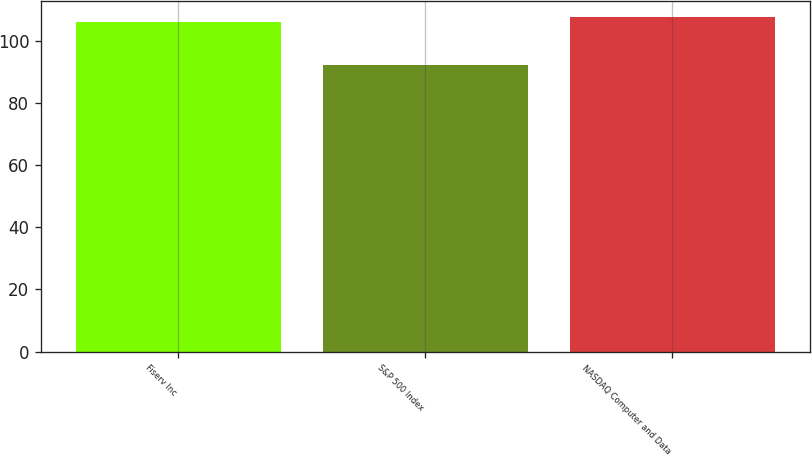<chart> <loc_0><loc_0><loc_500><loc_500><bar_chart><fcel>Fiserv Inc<fcel>S&P 500 Index<fcel>NASDAQ Computer and Data<nl><fcel>106<fcel>92<fcel>107.5<nl></chart> 